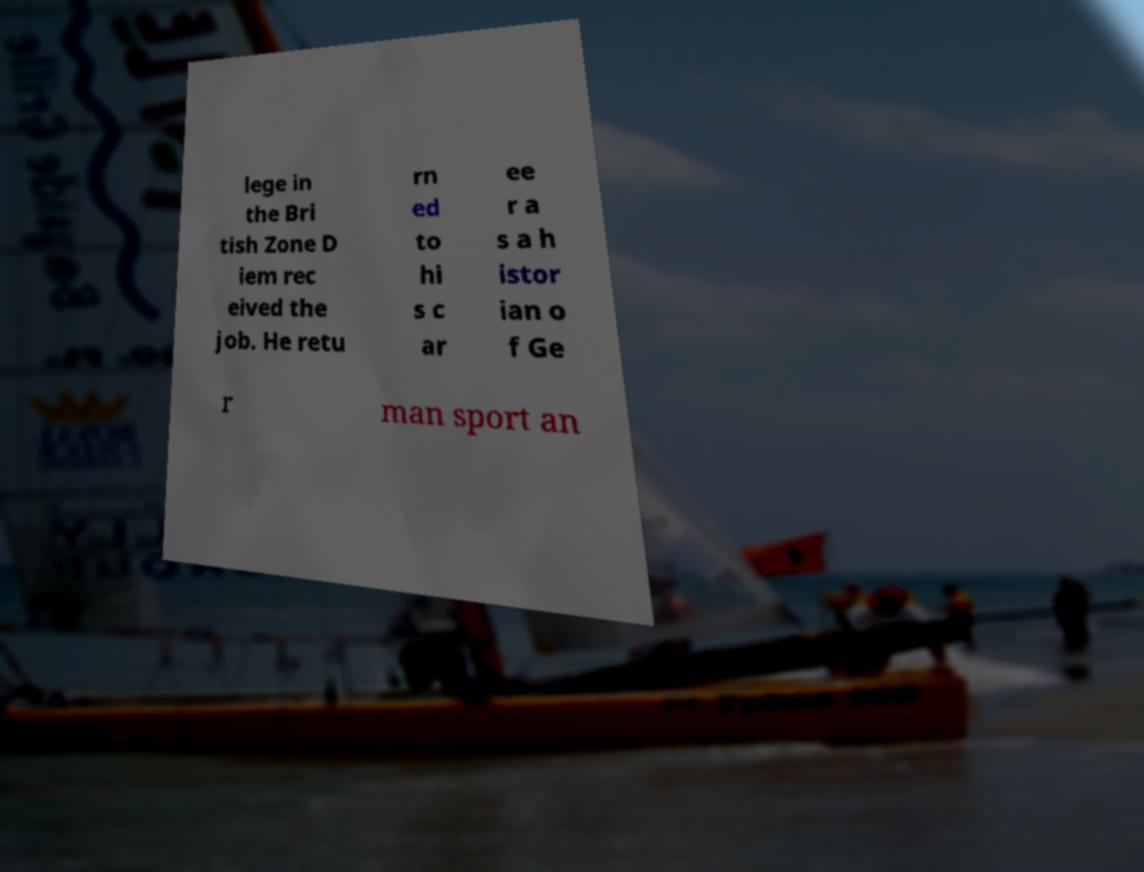There's text embedded in this image that I need extracted. Can you transcribe it verbatim? lege in the Bri tish Zone D iem rec eived the job. He retu rn ed to hi s c ar ee r a s a h istor ian o f Ge r man sport an 